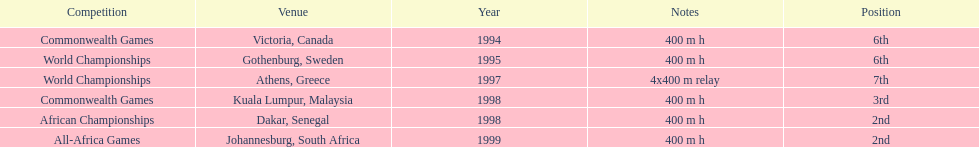How long was the relay at the 1997 world championships that ken harden ran 4x400 m relay. 